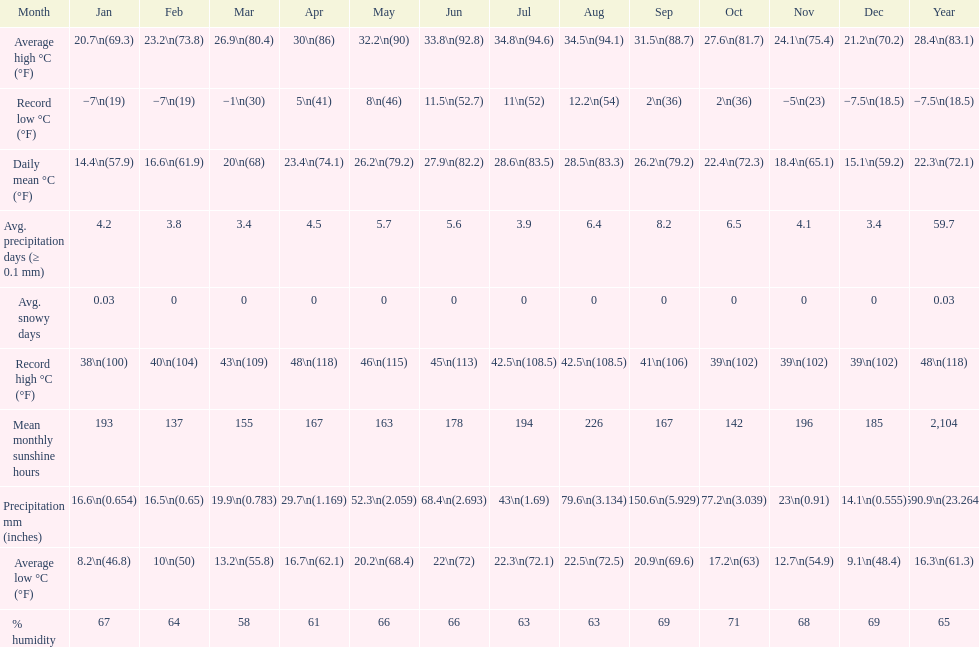Does december or january have more snow days? January. Would you mind parsing the complete table? {'header': ['Month', 'Jan', 'Feb', 'Mar', 'Apr', 'May', 'Jun', 'Jul', 'Aug', 'Sep', 'Oct', 'Nov', 'Dec', 'Year'], 'rows': [['Average high °C (°F)', '20.7\\n(69.3)', '23.2\\n(73.8)', '26.9\\n(80.4)', '30\\n(86)', '32.2\\n(90)', '33.8\\n(92.8)', '34.8\\n(94.6)', '34.5\\n(94.1)', '31.5\\n(88.7)', '27.6\\n(81.7)', '24.1\\n(75.4)', '21.2\\n(70.2)', '28.4\\n(83.1)'], ['Record low °C (°F)', '−7\\n(19)', '−7\\n(19)', '−1\\n(30)', '5\\n(41)', '8\\n(46)', '11.5\\n(52.7)', '11\\n(52)', '12.2\\n(54)', '2\\n(36)', '2\\n(36)', '−5\\n(23)', '−7.5\\n(18.5)', '−7.5\\n(18.5)'], ['Daily mean °C (°F)', '14.4\\n(57.9)', '16.6\\n(61.9)', '20\\n(68)', '23.4\\n(74.1)', '26.2\\n(79.2)', '27.9\\n(82.2)', '28.6\\n(83.5)', '28.5\\n(83.3)', '26.2\\n(79.2)', '22.4\\n(72.3)', '18.4\\n(65.1)', '15.1\\n(59.2)', '22.3\\n(72.1)'], ['Avg. precipitation days (≥ 0.1 mm)', '4.2', '3.8', '3.4', '4.5', '5.7', '5.6', '3.9', '6.4', '8.2', '6.5', '4.1', '3.4', '59.7'], ['Avg. snowy days', '0.03', '0', '0', '0', '0', '0', '0', '0', '0', '0', '0', '0', '0.03'], ['Record high °C (°F)', '38\\n(100)', '40\\n(104)', '43\\n(109)', '48\\n(118)', '46\\n(115)', '45\\n(113)', '42.5\\n(108.5)', '42.5\\n(108.5)', '41\\n(106)', '39\\n(102)', '39\\n(102)', '39\\n(102)', '48\\n(118)'], ['Mean monthly sunshine hours', '193', '137', '155', '167', '163', '178', '194', '226', '167', '142', '196', '185', '2,104'], ['Precipitation mm (inches)', '16.6\\n(0.654)', '16.5\\n(0.65)', '19.9\\n(0.783)', '29.7\\n(1.169)', '52.3\\n(2.059)', '68.4\\n(2.693)', '43\\n(1.69)', '79.6\\n(3.134)', '150.6\\n(5.929)', '77.2\\n(3.039)', '23\\n(0.91)', '14.1\\n(0.555)', '590.9\\n(23.264)'], ['Average low °C (°F)', '8.2\\n(46.8)', '10\\n(50)', '13.2\\n(55.8)', '16.7\\n(62.1)', '20.2\\n(68.4)', '22\\n(72)', '22.3\\n(72.1)', '22.5\\n(72.5)', '20.9\\n(69.6)', '17.2\\n(63)', '12.7\\n(54.9)', '9.1\\n(48.4)', '16.3\\n(61.3)'], ['% humidity', '67', '64', '58', '61', '66', '66', '63', '63', '69', '71', '68', '69', '65']]} 